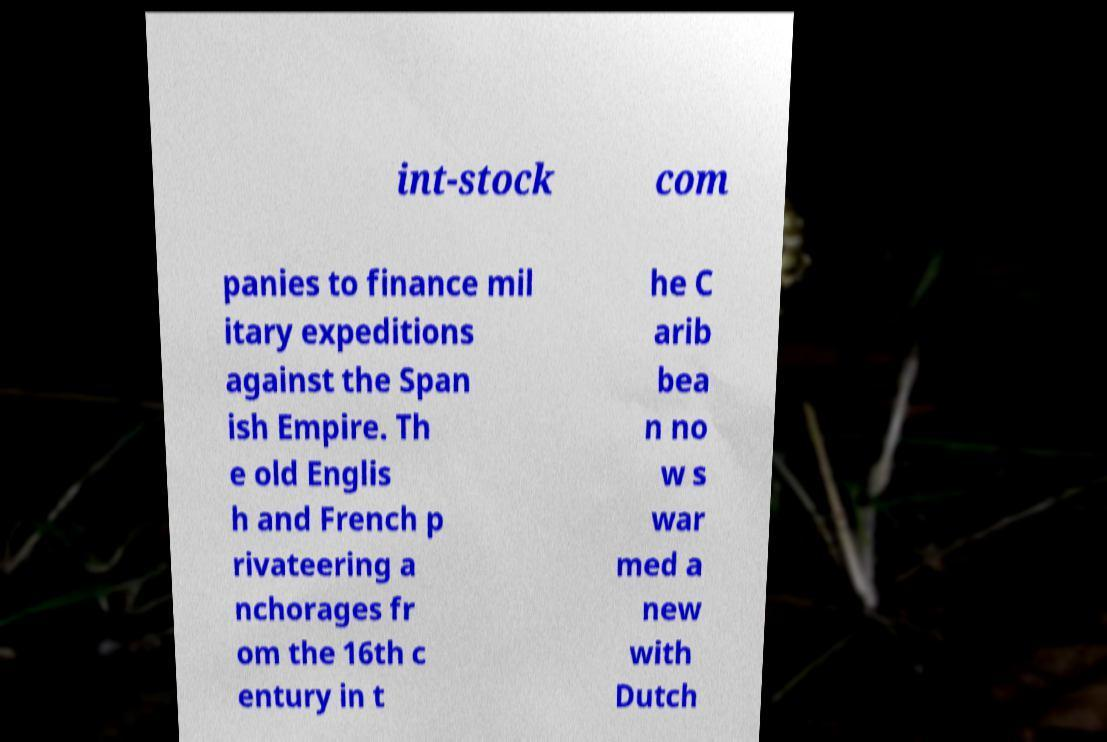There's text embedded in this image that I need extracted. Can you transcribe it verbatim? int-stock com panies to finance mil itary expeditions against the Span ish Empire. Th e old Englis h and French p rivateering a nchorages fr om the 16th c entury in t he C arib bea n no w s war med a new with Dutch 